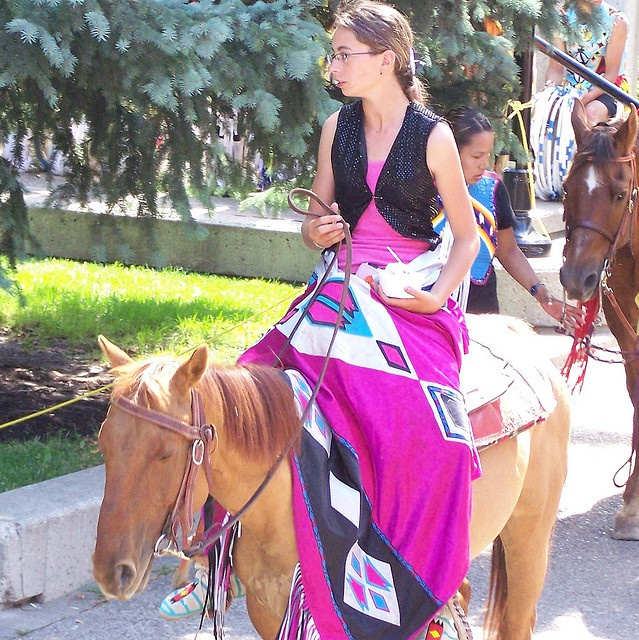Describe the objects in this image and their specific colors. I can see people in teal, white, magenta, and purple tones, horse in teal, brown, tan, and white tones, horse in teal, brown, and maroon tones, people in teal, white, darkgray, lightpink, and gray tones, and people in teal, brown, lightpink, gray, and darkgray tones in this image. 